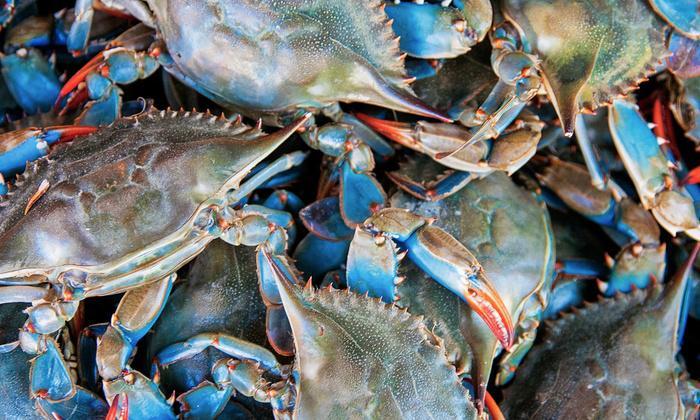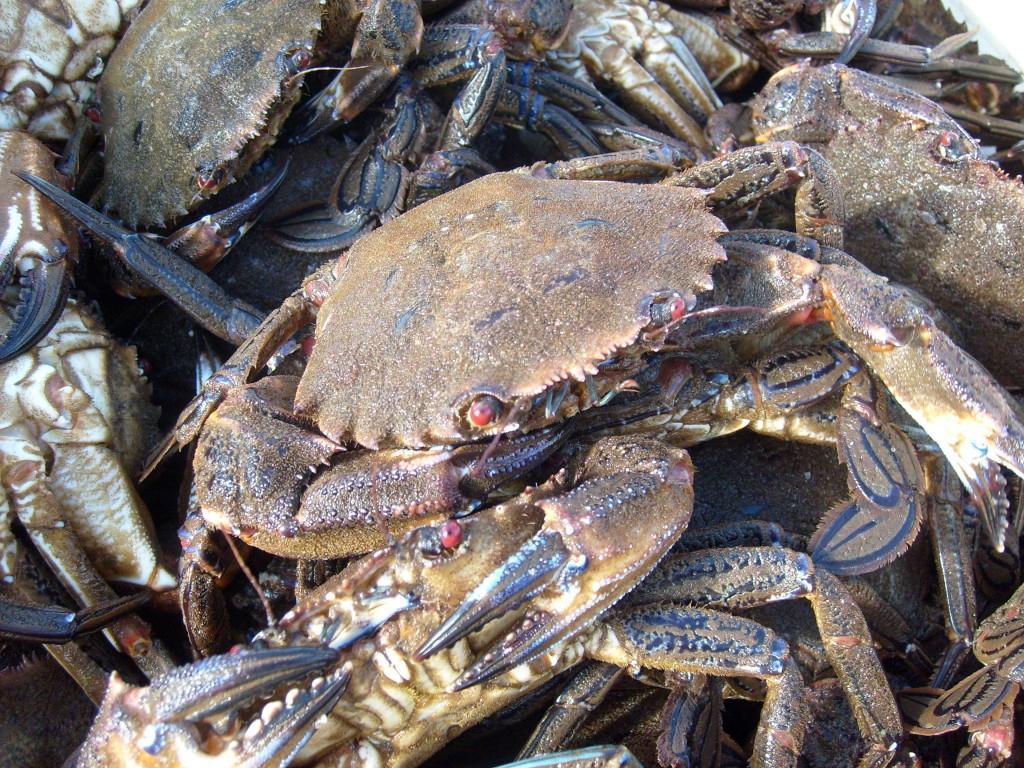The first image is the image on the left, the second image is the image on the right. Analyze the images presented: Is the assertion "The left image is a top-view of a pile of blue-gray crabs, and the right image is a more head-on view of multiple red-orange crabs." valid? Answer yes or no. No. The first image is the image on the left, the second image is the image on the right. Examine the images to the left and right. Is the description "There is one pile of gray crabs and one pile of red crabs." accurate? Answer yes or no. No. 